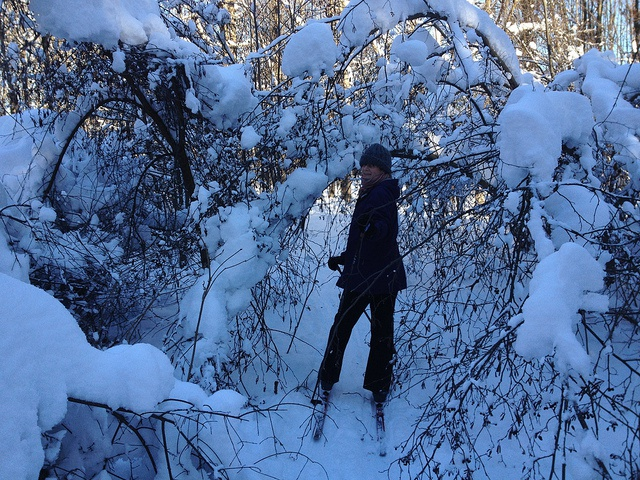Describe the objects in this image and their specific colors. I can see people in gray, black, navy, and darkblue tones and skis in gray, navy, black, and blue tones in this image. 